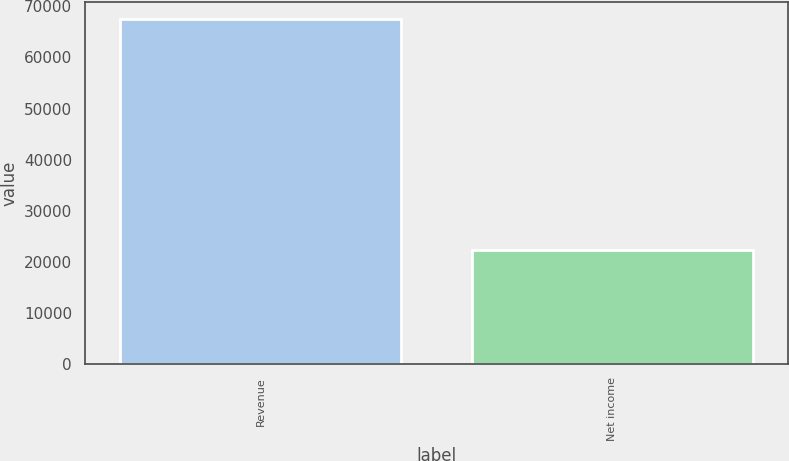<chart> <loc_0><loc_0><loc_500><loc_500><bar_chart><fcel>Revenue<fcel>Net income<nl><fcel>67453<fcel>22251<nl></chart> 